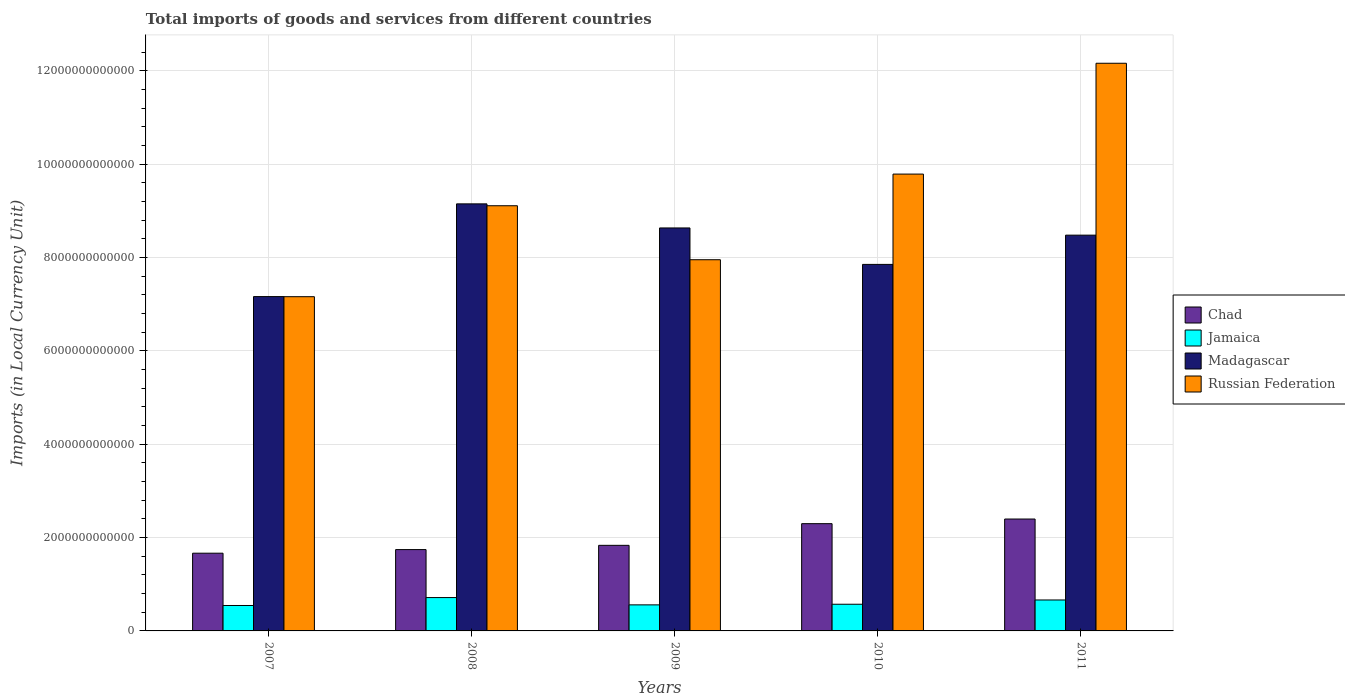How many different coloured bars are there?
Provide a short and direct response. 4. Are the number of bars per tick equal to the number of legend labels?
Offer a terse response. Yes. How many bars are there on the 5th tick from the left?
Make the answer very short. 4. What is the label of the 5th group of bars from the left?
Provide a succinct answer. 2011. What is the Amount of goods and services imports in Madagascar in 2010?
Your answer should be compact. 7.85e+12. Across all years, what is the maximum Amount of goods and services imports in Madagascar?
Your answer should be compact. 9.15e+12. Across all years, what is the minimum Amount of goods and services imports in Madagascar?
Offer a very short reply. 7.16e+12. In which year was the Amount of goods and services imports in Jamaica maximum?
Provide a succinct answer. 2008. In which year was the Amount of goods and services imports in Russian Federation minimum?
Keep it short and to the point. 2007. What is the total Amount of goods and services imports in Russian Federation in the graph?
Offer a terse response. 4.62e+13. What is the difference between the Amount of goods and services imports in Madagascar in 2007 and that in 2010?
Your answer should be compact. -6.90e+11. What is the difference between the Amount of goods and services imports in Madagascar in 2011 and the Amount of goods and services imports in Chad in 2010?
Offer a terse response. 6.18e+12. What is the average Amount of goods and services imports in Russian Federation per year?
Ensure brevity in your answer.  9.24e+12. In the year 2009, what is the difference between the Amount of goods and services imports in Madagascar and Amount of goods and services imports in Russian Federation?
Your answer should be very brief. 6.81e+11. What is the ratio of the Amount of goods and services imports in Russian Federation in 2007 to that in 2011?
Keep it short and to the point. 0.59. Is the difference between the Amount of goods and services imports in Madagascar in 2008 and 2011 greater than the difference between the Amount of goods and services imports in Russian Federation in 2008 and 2011?
Your response must be concise. Yes. What is the difference between the highest and the second highest Amount of goods and services imports in Jamaica?
Your answer should be very brief. 5.13e+1. What is the difference between the highest and the lowest Amount of goods and services imports in Jamaica?
Keep it short and to the point. 1.70e+11. In how many years, is the Amount of goods and services imports in Chad greater than the average Amount of goods and services imports in Chad taken over all years?
Provide a succinct answer. 2. Is the sum of the Amount of goods and services imports in Russian Federation in 2008 and 2009 greater than the maximum Amount of goods and services imports in Jamaica across all years?
Give a very brief answer. Yes. Is it the case that in every year, the sum of the Amount of goods and services imports in Jamaica and Amount of goods and services imports in Chad is greater than the sum of Amount of goods and services imports in Madagascar and Amount of goods and services imports in Russian Federation?
Give a very brief answer. No. What does the 3rd bar from the left in 2008 represents?
Keep it short and to the point. Madagascar. What does the 1st bar from the right in 2011 represents?
Your answer should be very brief. Russian Federation. How many years are there in the graph?
Your response must be concise. 5. What is the difference between two consecutive major ticks on the Y-axis?
Offer a very short reply. 2.00e+12. Are the values on the major ticks of Y-axis written in scientific E-notation?
Provide a short and direct response. No. How are the legend labels stacked?
Offer a terse response. Vertical. What is the title of the graph?
Your response must be concise. Total imports of goods and services from different countries. Does "World" appear as one of the legend labels in the graph?
Offer a terse response. No. What is the label or title of the Y-axis?
Ensure brevity in your answer.  Imports (in Local Currency Unit). What is the Imports (in Local Currency Unit) of Chad in 2007?
Offer a terse response. 1.67e+12. What is the Imports (in Local Currency Unit) in Jamaica in 2007?
Provide a succinct answer. 5.45e+11. What is the Imports (in Local Currency Unit) of Madagascar in 2007?
Provide a short and direct response. 7.16e+12. What is the Imports (in Local Currency Unit) in Russian Federation in 2007?
Provide a short and direct response. 7.16e+12. What is the Imports (in Local Currency Unit) of Chad in 2008?
Give a very brief answer. 1.74e+12. What is the Imports (in Local Currency Unit) of Jamaica in 2008?
Provide a succinct answer. 7.15e+11. What is the Imports (in Local Currency Unit) in Madagascar in 2008?
Provide a short and direct response. 9.15e+12. What is the Imports (in Local Currency Unit) of Russian Federation in 2008?
Offer a terse response. 9.11e+12. What is the Imports (in Local Currency Unit) in Chad in 2009?
Provide a succinct answer. 1.83e+12. What is the Imports (in Local Currency Unit) of Jamaica in 2009?
Your answer should be compact. 5.58e+11. What is the Imports (in Local Currency Unit) in Madagascar in 2009?
Make the answer very short. 8.64e+12. What is the Imports (in Local Currency Unit) of Russian Federation in 2009?
Make the answer very short. 7.95e+12. What is the Imports (in Local Currency Unit) of Chad in 2010?
Your answer should be compact. 2.30e+12. What is the Imports (in Local Currency Unit) in Jamaica in 2010?
Provide a short and direct response. 5.72e+11. What is the Imports (in Local Currency Unit) in Madagascar in 2010?
Provide a succinct answer. 7.85e+12. What is the Imports (in Local Currency Unit) of Russian Federation in 2010?
Your answer should be very brief. 9.79e+12. What is the Imports (in Local Currency Unit) in Chad in 2011?
Make the answer very short. 2.40e+12. What is the Imports (in Local Currency Unit) in Jamaica in 2011?
Offer a terse response. 6.63e+11. What is the Imports (in Local Currency Unit) of Madagascar in 2011?
Offer a very short reply. 8.48e+12. What is the Imports (in Local Currency Unit) in Russian Federation in 2011?
Your answer should be very brief. 1.22e+13. Across all years, what is the maximum Imports (in Local Currency Unit) in Chad?
Offer a very short reply. 2.40e+12. Across all years, what is the maximum Imports (in Local Currency Unit) in Jamaica?
Provide a succinct answer. 7.15e+11. Across all years, what is the maximum Imports (in Local Currency Unit) of Madagascar?
Give a very brief answer. 9.15e+12. Across all years, what is the maximum Imports (in Local Currency Unit) of Russian Federation?
Keep it short and to the point. 1.22e+13. Across all years, what is the minimum Imports (in Local Currency Unit) in Chad?
Make the answer very short. 1.67e+12. Across all years, what is the minimum Imports (in Local Currency Unit) of Jamaica?
Keep it short and to the point. 5.45e+11. Across all years, what is the minimum Imports (in Local Currency Unit) of Madagascar?
Your answer should be very brief. 7.16e+12. Across all years, what is the minimum Imports (in Local Currency Unit) of Russian Federation?
Your answer should be compact. 7.16e+12. What is the total Imports (in Local Currency Unit) in Chad in the graph?
Keep it short and to the point. 9.94e+12. What is the total Imports (in Local Currency Unit) of Jamaica in the graph?
Give a very brief answer. 3.05e+12. What is the total Imports (in Local Currency Unit) of Madagascar in the graph?
Ensure brevity in your answer.  4.13e+13. What is the total Imports (in Local Currency Unit) in Russian Federation in the graph?
Offer a terse response. 4.62e+13. What is the difference between the Imports (in Local Currency Unit) of Chad in 2007 and that in 2008?
Give a very brief answer. -7.73e+1. What is the difference between the Imports (in Local Currency Unit) in Jamaica in 2007 and that in 2008?
Your answer should be compact. -1.70e+11. What is the difference between the Imports (in Local Currency Unit) in Madagascar in 2007 and that in 2008?
Your response must be concise. -1.99e+12. What is the difference between the Imports (in Local Currency Unit) in Russian Federation in 2007 and that in 2008?
Your response must be concise. -1.95e+12. What is the difference between the Imports (in Local Currency Unit) in Chad in 2007 and that in 2009?
Your answer should be compact. -1.68e+11. What is the difference between the Imports (in Local Currency Unit) in Jamaica in 2007 and that in 2009?
Your response must be concise. -1.35e+1. What is the difference between the Imports (in Local Currency Unit) of Madagascar in 2007 and that in 2009?
Give a very brief answer. -1.47e+12. What is the difference between the Imports (in Local Currency Unit) in Russian Federation in 2007 and that in 2009?
Keep it short and to the point. -7.92e+11. What is the difference between the Imports (in Local Currency Unit) in Chad in 2007 and that in 2010?
Offer a very short reply. -6.33e+11. What is the difference between the Imports (in Local Currency Unit) of Jamaica in 2007 and that in 2010?
Make the answer very short. -2.68e+1. What is the difference between the Imports (in Local Currency Unit) in Madagascar in 2007 and that in 2010?
Provide a short and direct response. -6.90e+11. What is the difference between the Imports (in Local Currency Unit) in Russian Federation in 2007 and that in 2010?
Keep it short and to the point. -2.63e+12. What is the difference between the Imports (in Local Currency Unit) of Chad in 2007 and that in 2011?
Make the answer very short. -7.32e+11. What is the difference between the Imports (in Local Currency Unit) in Jamaica in 2007 and that in 2011?
Your answer should be very brief. -1.18e+11. What is the difference between the Imports (in Local Currency Unit) of Madagascar in 2007 and that in 2011?
Provide a short and direct response. -1.32e+12. What is the difference between the Imports (in Local Currency Unit) of Russian Federation in 2007 and that in 2011?
Your answer should be very brief. -5.00e+12. What is the difference between the Imports (in Local Currency Unit) of Chad in 2008 and that in 2009?
Offer a terse response. -9.11e+1. What is the difference between the Imports (in Local Currency Unit) in Jamaica in 2008 and that in 2009?
Your answer should be very brief. 1.56e+11. What is the difference between the Imports (in Local Currency Unit) in Madagascar in 2008 and that in 2009?
Give a very brief answer. 5.16e+11. What is the difference between the Imports (in Local Currency Unit) of Russian Federation in 2008 and that in 2009?
Give a very brief answer. 1.16e+12. What is the difference between the Imports (in Local Currency Unit) in Chad in 2008 and that in 2010?
Make the answer very short. -5.56e+11. What is the difference between the Imports (in Local Currency Unit) of Jamaica in 2008 and that in 2010?
Offer a very short reply. 1.43e+11. What is the difference between the Imports (in Local Currency Unit) of Madagascar in 2008 and that in 2010?
Provide a short and direct response. 1.30e+12. What is the difference between the Imports (in Local Currency Unit) in Russian Federation in 2008 and that in 2010?
Keep it short and to the point. -6.79e+11. What is the difference between the Imports (in Local Currency Unit) of Chad in 2008 and that in 2011?
Ensure brevity in your answer.  -6.55e+11. What is the difference between the Imports (in Local Currency Unit) of Jamaica in 2008 and that in 2011?
Give a very brief answer. 5.13e+1. What is the difference between the Imports (in Local Currency Unit) in Madagascar in 2008 and that in 2011?
Give a very brief answer. 6.70e+11. What is the difference between the Imports (in Local Currency Unit) in Russian Federation in 2008 and that in 2011?
Your response must be concise. -3.05e+12. What is the difference between the Imports (in Local Currency Unit) in Chad in 2009 and that in 2010?
Your answer should be very brief. -4.65e+11. What is the difference between the Imports (in Local Currency Unit) in Jamaica in 2009 and that in 2010?
Offer a terse response. -1.33e+1. What is the difference between the Imports (in Local Currency Unit) in Madagascar in 2009 and that in 2010?
Offer a terse response. 7.81e+11. What is the difference between the Imports (in Local Currency Unit) in Russian Federation in 2009 and that in 2010?
Make the answer very short. -1.84e+12. What is the difference between the Imports (in Local Currency Unit) in Chad in 2009 and that in 2011?
Offer a very short reply. -5.64e+11. What is the difference between the Imports (in Local Currency Unit) in Jamaica in 2009 and that in 2011?
Give a very brief answer. -1.05e+11. What is the difference between the Imports (in Local Currency Unit) in Madagascar in 2009 and that in 2011?
Give a very brief answer. 1.54e+11. What is the difference between the Imports (in Local Currency Unit) of Russian Federation in 2009 and that in 2011?
Offer a very short reply. -4.21e+12. What is the difference between the Imports (in Local Currency Unit) in Chad in 2010 and that in 2011?
Provide a short and direct response. -9.94e+1. What is the difference between the Imports (in Local Currency Unit) in Jamaica in 2010 and that in 2011?
Make the answer very short. -9.16e+1. What is the difference between the Imports (in Local Currency Unit) in Madagascar in 2010 and that in 2011?
Offer a terse response. -6.27e+11. What is the difference between the Imports (in Local Currency Unit) in Russian Federation in 2010 and that in 2011?
Your answer should be very brief. -2.37e+12. What is the difference between the Imports (in Local Currency Unit) of Chad in 2007 and the Imports (in Local Currency Unit) of Jamaica in 2008?
Your answer should be very brief. 9.51e+11. What is the difference between the Imports (in Local Currency Unit) of Chad in 2007 and the Imports (in Local Currency Unit) of Madagascar in 2008?
Provide a short and direct response. -7.49e+12. What is the difference between the Imports (in Local Currency Unit) in Chad in 2007 and the Imports (in Local Currency Unit) in Russian Federation in 2008?
Your answer should be compact. -7.45e+12. What is the difference between the Imports (in Local Currency Unit) in Jamaica in 2007 and the Imports (in Local Currency Unit) in Madagascar in 2008?
Your answer should be very brief. -8.61e+12. What is the difference between the Imports (in Local Currency Unit) in Jamaica in 2007 and the Imports (in Local Currency Unit) in Russian Federation in 2008?
Provide a succinct answer. -8.57e+12. What is the difference between the Imports (in Local Currency Unit) in Madagascar in 2007 and the Imports (in Local Currency Unit) in Russian Federation in 2008?
Ensure brevity in your answer.  -1.95e+12. What is the difference between the Imports (in Local Currency Unit) of Chad in 2007 and the Imports (in Local Currency Unit) of Jamaica in 2009?
Your answer should be very brief. 1.11e+12. What is the difference between the Imports (in Local Currency Unit) in Chad in 2007 and the Imports (in Local Currency Unit) in Madagascar in 2009?
Offer a very short reply. -6.97e+12. What is the difference between the Imports (in Local Currency Unit) of Chad in 2007 and the Imports (in Local Currency Unit) of Russian Federation in 2009?
Your response must be concise. -6.29e+12. What is the difference between the Imports (in Local Currency Unit) in Jamaica in 2007 and the Imports (in Local Currency Unit) in Madagascar in 2009?
Ensure brevity in your answer.  -8.09e+12. What is the difference between the Imports (in Local Currency Unit) of Jamaica in 2007 and the Imports (in Local Currency Unit) of Russian Federation in 2009?
Provide a short and direct response. -7.41e+12. What is the difference between the Imports (in Local Currency Unit) of Madagascar in 2007 and the Imports (in Local Currency Unit) of Russian Federation in 2009?
Your response must be concise. -7.90e+11. What is the difference between the Imports (in Local Currency Unit) of Chad in 2007 and the Imports (in Local Currency Unit) of Jamaica in 2010?
Keep it short and to the point. 1.09e+12. What is the difference between the Imports (in Local Currency Unit) in Chad in 2007 and the Imports (in Local Currency Unit) in Madagascar in 2010?
Give a very brief answer. -6.19e+12. What is the difference between the Imports (in Local Currency Unit) in Chad in 2007 and the Imports (in Local Currency Unit) in Russian Federation in 2010?
Your answer should be compact. -8.12e+12. What is the difference between the Imports (in Local Currency Unit) of Jamaica in 2007 and the Imports (in Local Currency Unit) of Madagascar in 2010?
Give a very brief answer. -7.31e+12. What is the difference between the Imports (in Local Currency Unit) of Jamaica in 2007 and the Imports (in Local Currency Unit) of Russian Federation in 2010?
Give a very brief answer. -9.24e+12. What is the difference between the Imports (in Local Currency Unit) in Madagascar in 2007 and the Imports (in Local Currency Unit) in Russian Federation in 2010?
Your response must be concise. -2.63e+12. What is the difference between the Imports (in Local Currency Unit) of Chad in 2007 and the Imports (in Local Currency Unit) of Jamaica in 2011?
Ensure brevity in your answer.  1.00e+12. What is the difference between the Imports (in Local Currency Unit) of Chad in 2007 and the Imports (in Local Currency Unit) of Madagascar in 2011?
Provide a succinct answer. -6.82e+12. What is the difference between the Imports (in Local Currency Unit) of Chad in 2007 and the Imports (in Local Currency Unit) of Russian Federation in 2011?
Keep it short and to the point. -1.05e+13. What is the difference between the Imports (in Local Currency Unit) in Jamaica in 2007 and the Imports (in Local Currency Unit) in Madagascar in 2011?
Your answer should be very brief. -7.94e+12. What is the difference between the Imports (in Local Currency Unit) in Jamaica in 2007 and the Imports (in Local Currency Unit) in Russian Federation in 2011?
Make the answer very short. -1.16e+13. What is the difference between the Imports (in Local Currency Unit) of Madagascar in 2007 and the Imports (in Local Currency Unit) of Russian Federation in 2011?
Your answer should be compact. -5.00e+12. What is the difference between the Imports (in Local Currency Unit) of Chad in 2008 and the Imports (in Local Currency Unit) of Jamaica in 2009?
Provide a short and direct response. 1.18e+12. What is the difference between the Imports (in Local Currency Unit) of Chad in 2008 and the Imports (in Local Currency Unit) of Madagascar in 2009?
Your answer should be very brief. -6.89e+12. What is the difference between the Imports (in Local Currency Unit) in Chad in 2008 and the Imports (in Local Currency Unit) in Russian Federation in 2009?
Your answer should be compact. -6.21e+12. What is the difference between the Imports (in Local Currency Unit) in Jamaica in 2008 and the Imports (in Local Currency Unit) in Madagascar in 2009?
Your response must be concise. -7.92e+12. What is the difference between the Imports (in Local Currency Unit) of Jamaica in 2008 and the Imports (in Local Currency Unit) of Russian Federation in 2009?
Keep it short and to the point. -7.24e+12. What is the difference between the Imports (in Local Currency Unit) of Madagascar in 2008 and the Imports (in Local Currency Unit) of Russian Federation in 2009?
Make the answer very short. 1.20e+12. What is the difference between the Imports (in Local Currency Unit) in Chad in 2008 and the Imports (in Local Currency Unit) in Jamaica in 2010?
Offer a very short reply. 1.17e+12. What is the difference between the Imports (in Local Currency Unit) of Chad in 2008 and the Imports (in Local Currency Unit) of Madagascar in 2010?
Keep it short and to the point. -6.11e+12. What is the difference between the Imports (in Local Currency Unit) of Chad in 2008 and the Imports (in Local Currency Unit) of Russian Federation in 2010?
Give a very brief answer. -8.05e+12. What is the difference between the Imports (in Local Currency Unit) of Jamaica in 2008 and the Imports (in Local Currency Unit) of Madagascar in 2010?
Your answer should be very brief. -7.14e+12. What is the difference between the Imports (in Local Currency Unit) in Jamaica in 2008 and the Imports (in Local Currency Unit) in Russian Federation in 2010?
Give a very brief answer. -9.08e+12. What is the difference between the Imports (in Local Currency Unit) of Madagascar in 2008 and the Imports (in Local Currency Unit) of Russian Federation in 2010?
Your answer should be very brief. -6.38e+11. What is the difference between the Imports (in Local Currency Unit) in Chad in 2008 and the Imports (in Local Currency Unit) in Jamaica in 2011?
Offer a terse response. 1.08e+12. What is the difference between the Imports (in Local Currency Unit) in Chad in 2008 and the Imports (in Local Currency Unit) in Madagascar in 2011?
Ensure brevity in your answer.  -6.74e+12. What is the difference between the Imports (in Local Currency Unit) of Chad in 2008 and the Imports (in Local Currency Unit) of Russian Federation in 2011?
Provide a succinct answer. -1.04e+13. What is the difference between the Imports (in Local Currency Unit) of Jamaica in 2008 and the Imports (in Local Currency Unit) of Madagascar in 2011?
Keep it short and to the point. -7.77e+12. What is the difference between the Imports (in Local Currency Unit) in Jamaica in 2008 and the Imports (in Local Currency Unit) in Russian Federation in 2011?
Offer a terse response. -1.14e+13. What is the difference between the Imports (in Local Currency Unit) in Madagascar in 2008 and the Imports (in Local Currency Unit) in Russian Federation in 2011?
Provide a short and direct response. -3.01e+12. What is the difference between the Imports (in Local Currency Unit) in Chad in 2009 and the Imports (in Local Currency Unit) in Jamaica in 2010?
Your answer should be very brief. 1.26e+12. What is the difference between the Imports (in Local Currency Unit) of Chad in 2009 and the Imports (in Local Currency Unit) of Madagascar in 2010?
Your response must be concise. -6.02e+12. What is the difference between the Imports (in Local Currency Unit) of Chad in 2009 and the Imports (in Local Currency Unit) of Russian Federation in 2010?
Offer a terse response. -7.96e+12. What is the difference between the Imports (in Local Currency Unit) of Jamaica in 2009 and the Imports (in Local Currency Unit) of Madagascar in 2010?
Make the answer very short. -7.30e+12. What is the difference between the Imports (in Local Currency Unit) in Jamaica in 2009 and the Imports (in Local Currency Unit) in Russian Federation in 2010?
Provide a short and direct response. -9.23e+12. What is the difference between the Imports (in Local Currency Unit) in Madagascar in 2009 and the Imports (in Local Currency Unit) in Russian Federation in 2010?
Offer a very short reply. -1.15e+12. What is the difference between the Imports (in Local Currency Unit) in Chad in 2009 and the Imports (in Local Currency Unit) in Jamaica in 2011?
Provide a succinct answer. 1.17e+12. What is the difference between the Imports (in Local Currency Unit) in Chad in 2009 and the Imports (in Local Currency Unit) in Madagascar in 2011?
Offer a terse response. -6.65e+12. What is the difference between the Imports (in Local Currency Unit) of Chad in 2009 and the Imports (in Local Currency Unit) of Russian Federation in 2011?
Provide a short and direct response. -1.03e+13. What is the difference between the Imports (in Local Currency Unit) of Jamaica in 2009 and the Imports (in Local Currency Unit) of Madagascar in 2011?
Keep it short and to the point. -7.92e+12. What is the difference between the Imports (in Local Currency Unit) of Jamaica in 2009 and the Imports (in Local Currency Unit) of Russian Federation in 2011?
Make the answer very short. -1.16e+13. What is the difference between the Imports (in Local Currency Unit) in Madagascar in 2009 and the Imports (in Local Currency Unit) in Russian Federation in 2011?
Make the answer very short. -3.53e+12. What is the difference between the Imports (in Local Currency Unit) in Chad in 2010 and the Imports (in Local Currency Unit) in Jamaica in 2011?
Offer a terse response. 1.64e+12. What is the difference between the Imports (in Local Currency Unit) of Chad in 2010 and the Imports (in Local Currency Unit) of Madagascar in 2011?
Provide a short and direct response. -6.18e+12. What is the difference between the Imports (in Local Currency Unit) in Chad in 2010 and the Imports (in Local Currency Unit) in Russian Federation in 2011?
Give a very brief answer. -9.87e+12. What is the difference between the Imports (in Local Currency Unit) in Jamaica in 2010 and the Imports (in Local Currency Unit) in Madagascar in 2011?
Your answer should be very brief. -7.91e+12. What is the difference between the Imports (in Local Currency Unit) in Jamaica in 2010 and the Imports (in Local Currency Unit) in Russian Federation in 2011?
Give a very brief answer. -1.16e+13. What is the difference between the Imports (in Local Currency Unit) of Madagascar in 2010 and the Imports (in Local Currency Unit) of Russian Federation in 2011?
Offer a terse response. -4.31e+12. What is the average Imports (in Local Currency Unit) in Chad per year?
Give a very brief answer. 1.99e+12. What is the average Imports (in Local Currency Unit) of Jamaica per year?
Your answer should be compact. 6.10e+11. What is the average Imports (in Local Currency Unit) in Madagascar per year?
Your response must be concise. 8.26e+12. What is the average Imports (in Local Currency Unit) of Russian Federation per year?
Ensure brevity in your answer.  9.24e+12. In the year 2007, what is the difference between the Imports (in Local Currency Unit) in Chad and Imports (in Local Currency Unit) in Jamaica?
Offer a very short reply. 1.12e+12. In the year 2007, what is the difference between the Imports (in Local Currency Unit) of Chad and Imports (in Local Currency Unit) of Madagascar?
Offer a terse response. -5.50e+12. In the year 2007, what is the difference between the Imports (in Local Currency Unit) in Chad and Imports (in Local Currency Unit) in Russian Federation?
Provide a short and direct response. -5.50e+12. In the year 2007, what is the difference between the Imports (in Local Currency Unit) of Jamaica and Imports (in Local Currency Unit) of Madagascar?
Offer a very short reply. -6.62e+12. In the year 2007, what is the difference between the Imports (in Local Currency Unit) of Jamaica and Imports (in Local Currency Unit) of Russian Federation?
Offer a very short reply. -6.62e+12. In the year 2007, what is the difference between the Imports (in Local Currency Unit) in Madagascar and Imports (in Local Currency Unit) in Russian Federation?
Your answer should be compact. 2.10e+09. In the year 2008, what is the difference between the Imports (in Local Currency Unit) in Chad and Imports (in Local Currency Unit) in Jamaica?
Keep it short and to the point. 1.03e+12. In the year 2008, what is the difference between the Imports (in Local Currency Unit) of Chad and Imports (in Local Currency Unit) of Madagascar?
Your answer should be very brief. -7.41e+12. In the year 2008, what is the difference between the Imports (in Local Currency Unit) of Chad and Imports (in Local Currency Unit) of Russian Federation?
Ensure brevity in your answer.  -7.37e+12. In the year 2008, what is the difference between the Imports (in Local Currency Unit) of Jamaica and Imports (in Local Currency Unit) of Madagascar?
Provide a succinct answer. -8.44e+12. In the year 2008, what is the difference between the Imports (in Local Currency Unit) of Jamaica and Imports (in Local Currency Unit) of Russian Federation?
Keep it short and to the point. -8.40e+12. In the year 2008, what is the difference between the Imports (in Local Currency Unit) in Madagascar and Imports (in Local Currency Unit) in Russian Federation?
Keep it short and to the point. 4.04e+1. In the year 2009, what is the difference between the Imports (in Local Currency Unit) of Chad and Imports (in Local Currency Unit) of Jamaica?
Give a very brief answer. 1.28e+12. In the year 2009, what is the difference between the Imports (in Local Currency Unit) of Chad and Imports (in Local Currency Unit) of Madagascar?
Provide a short and direct response. -6.80e+12. In the year 2009, what is the difference between the Imports (in Local Currency Unit) in Chad and Imports (in Local Currency Unit) in Russian Federation?
Ensure brevity in your answer.  -6.12e+12. In the year 2009, what is the difference between the Imports (in Local Currency Unit) in Jamaica and Imports (in Local Currency Unit) in Madagascar?
Keep it short and to the point. -8.08e+12. In the year 2009, what is the difference between the Imports (in Local Currency Unit) of Jamaica and Imports (in Local Currency Unit) of Russian Federation?
Provide a succinct answer. -7.40e+12. In the year 2009, what is the difference between the Imports (in Local Currency Unit) of Madagascar and Imports (in Local Currency Unit) of Russian Federation?
Provide a succinct answer. 6.81e+11. In the year 2010, what is the difference between the Imports (in Local Currency Unit) in Chad and Imports (in Local Currency Unit) in Jamaica?
Provide a succinct answer. 1.73e+12. In the year 2010, what is the difference between the Imports (in Local Currency Unit) in Chad and Imports (in Local Currency Unit) in Madagascar?
Offer a very short reply. -5.56e+12. In the year 2010, what is the difference between the Imports (in Local Currency Unit) of Chad and Imports (in Local Currency Unit) of Russian Federation?
Your response must be concise. -7.49e+12. In the year 2010, what is the difference between the Imports (in Local Currency Unit) in Jamaica and Imports (in Local Currency Unit) in Madagascar?
Offer a terse response. -7.28e+12. In the year 2010, what is the difference between the Imports (in Local Currency Unit) in Jamaica and Imports (in Local Currency Unit) in Russian Federation?
Give a very brief answer. -9.22e+12. In the year 2010, what is the difference between the Imports (in Local Currency Unit) of Madagascar and Imports (in Local Currency Unit) of Russian Federation?
Give a very brief answer. -1.94e+12. In the year 2011, what is the difference between the Imports (in Local Currency Unit) in Chad and Imports (in Local Currency Unit) in Jamaica?
Your answer should be compact. 1.73e+12. In the year 2011, what is the difference between the Imports (in Local Currency Unit) of Chad and Imports (in Local Currency Unit) of Madagascar?
Provide a succinct answer. -6.08e+12. In the year 2011, what is the difference between the Imports (in Local Currency Unit) of Chad and Imports (in Local Currency Unit) of Russian Federation?
Your answer should be very brief. -9.77e+12. In the year 2011, what is the difference between the Imports (in Local Currency Unit) in Jamaica and Imports (in Local Currency Unit) in Madagascar?
Your answer should be very brief. -7.82e+12. In the year 2011, what is the difference between the Imports (in Local Currency Unit) in Jamaica and Imports (in Local Currency Unit) in Russian Federation?
Your answer should be very brief. -1.15e+13. In the year 2011, what is the difference between the Imports (in Local Currency Unit) in Madagascar and Imports (in Local Currency Unit) in Russian Federation?
Provide a short and direct response. -3.68e+12. What is the ratio of the Imports (in Local Currency Unit) in Chad in 2007 to that in 2008?
Provide a succinct answer. 0.96. What is the ratio of the Imports (in Local Currency Unit) of Jamaica in 2007 to that in 2008?
Offer a very short reply. 0.76. What is the ratio of the Imports (in Local Currency Unit) in Madagascar in 2007 to that in 2008?
Give a very brief answer. 0.78. What is the ratio of the Imports (in Local Currency Unit) in Russian Federation in 2007 to that in 2008?
Provide a succinct answer. 0.79. What is the ratio of the Imports (in Local Currency Unit) of Chad in 2007 to that in 2009?
Your answer should be very brief. 0.91. What is the ratio of the Imports (in Local Currency Unit) in Jamaica in 2007 to that in 2009?
Provide a short and direct response. 0.98. What is the ratio of the Imports (in Local Currency Unit) in Madagascar in 2007 to that in 2009?
Offer a very short reply. 0.83. What is the ratio of the Imports (in Local Currency Unit) in Russian Federation in 2007 to that in 2009?
Ensure brevity in your answer.  0.9. What is the ratio of the Imports (in Local Currency Unit) of Chad in 2007 to that in 2010?
Offer a terse response. 0.72. What is the ratio of the Imports (in Local Currency Unit) in Jamaica in 2007 to that in 2010?
Provide a succinct answer. 0.95. What is the ratio of the Imports (in Local Currency Unit) of Madagascar in 2007 to that in 2010?
Keep it short and to the point. 0.91. What is the ratio of the Imports (in Local Currency Unit) in Russian Federation in 2007 to that in 2010?
Provide a succinct answer. 0.73. What is the ratio of the Imports (in Local Currency Unit) of Chad in 2007 to that in 2011?
Provide a succinct answer. 0.69. What is the ratio of the Imports (in Local Currency Unit) in Jamaica in 2007 to that in 2011?
Provide a short and direct response. 0.82. What is the ratio of the Imports (in Local Currency Unit) of Madagascar in 2007 to that in 2011?
Provide a succinct answer. 0.84. What is the ratio of the Imports (in Local Currency Unit) in Russian Federation in 2007 to that in 2011?
Your response must be concise. 0.59. What is the ratio of the Imports (in Local Currency Unit) in Chad in 2008 to that in 2009?
Offer a terse response. 0.95. What is the ratio of the Imports (in Local Currency Unit) of Jamaica in 2008 to that in 2009?
Keep it short and to the point. 1.28. What is the ratio of the Imports (in Local Currency Unit) in Madagascar in 2008 to that in 2009?
Provide a short and direct response. 1.06. What is the ratio of the Imports (in Local Currency Unit) of Russian Federation in 2008 to that in 2009?
Give a very brief answer. 1.15. What is the ratio of the Imports (in Local Currency Unit) of Chad in 2008 to that in 2010?
Offer a very short reply. 0.76. What is the ratio of the Imports (in Local Currency Unit) in Jamaica in 2008 to that in 2010?
Make the answer very short. 1.25. What is the ratio of the Imports (in Local Currency Unit) of Madagascar in 2008 to that in 2010?
Give a very brief answer. 1.17. What is the ratio of the Imports (in Local Currency Unit) of Russian Federation in 2008 to that in 2010?
Provide a succinct answer. 0.93. What is the ratio of the Imports (in Local Currency Unit) in Chad in 2008 to that in 2011?
Your response must be concise. 0.73. What is the ratio of the Imports (in Local Currency Unit) in Jamaica in 2008 to that in 2011?
Offer a very short reply. 1.08. What is the ratio of the Imports (in Local Currency Unit) of Madagascar in 2008 to that in 2011?
Ensure brevity in your answer.  1.08. What is the ratio of the Imports (in Local Currency Unit) of Russian Federation in 2008 to that in 2011?
Offer a terse response. 0.75. What is the ratio of the Imports (in Local Currency Unit) of Chad in 2009 to that in 2010?
Provide a succinct answer. 0.8. What is the ratio of the Imports (in Local Currency Unit) of Jamaica in 2009 to that in 2010?
Offer a very short reply. 0.98. What is the ratio of the Imports (in Local Currency Unit) in Madagascar in 2009 to that in 2010?
Make the answer very short. 1.1. What is the ratio of the Imports (in Local Currency Unit) of Russian Federation in 2009 to that in 2010?
Ensure brevity in your answer.  0.81. What is the ratio of the Imports (in Local Currency Unit) in Chad in 2009 to that in 2011?
Your response must be concise. 0.76. What is the ratio of the Imports (in Local Currency Unit) in Jamaica in 2009 to that in 2011?
Keep it short and to the point. 0.84. What is the ratio of the Imports (in Local Currency Unit) in Madagascar in 2009 to that in 2011?
Keep it short and to the point. 1.02. What is the ratio of the Imports (in Local Currency Unit) in Russian Federation in 2009 to that in 2011?
Make the answer very short. 0.65. What is the ratio of the Imports (in Local Currency Unit) in Chad in 2010 to that in 2011?
Offer a terse response. 0.96. What is the ratio of the Imports (in Local Currency Unit) in Jamaica in 2010 to that in 2011?
Your response must be concise. 0.86. What is the ratio of the Imports (in Local Currency Unit) in Madagascar in 2010 to that in 2011?
Give a very brief answer. 0.93. What is the ratio of the Imports (in Local Currency Unit) in Russian Federation in 2010 to that in 2011?
Ensure brevity in your answer.  0.8. What is the difference between the highest and the second highest Imports (in Local Currency Unit) in Chad?
Your answer should be very brief. 9.94e+1. What is the difference between the highest and the second highest Imports (in Local Currency Unit) of Jamaica?
Provide a succinct answer. 5.13e+1. What is the difference between the highest and the second highest Imports (in Local Currency Unit) in Madagascar?
Your answer should be compact. 5.16e+11. What is the difference between the highest and the second highest Imports (in Local Currency Unit) of Russian Federation?
Provide a succinct answer. 2.37e+12. What is the difference between the highest and the lowest Imports (in Local Currency Unit) in Chad?
Your response must be concise. 7.32e+11. What is the difference between the highest and the lowest Imports (in Local Currency Unit) in Jamaica?
Your answer should be compact. 1.70e+11. What is the difference between the highest and the lowest Imports (in Local Currency Unit) in Madagascar?
Ensure brevity in your answer.  1.99e+12. What is the difference between the highest and the lowest Imports (in Local Currency Unit) of Russian Federation?
Provide a succinct answer. 5.00e+12. 